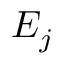<formula> <loc_0><loc_0><loc_500><loc_500>E _ { j }</formula> 